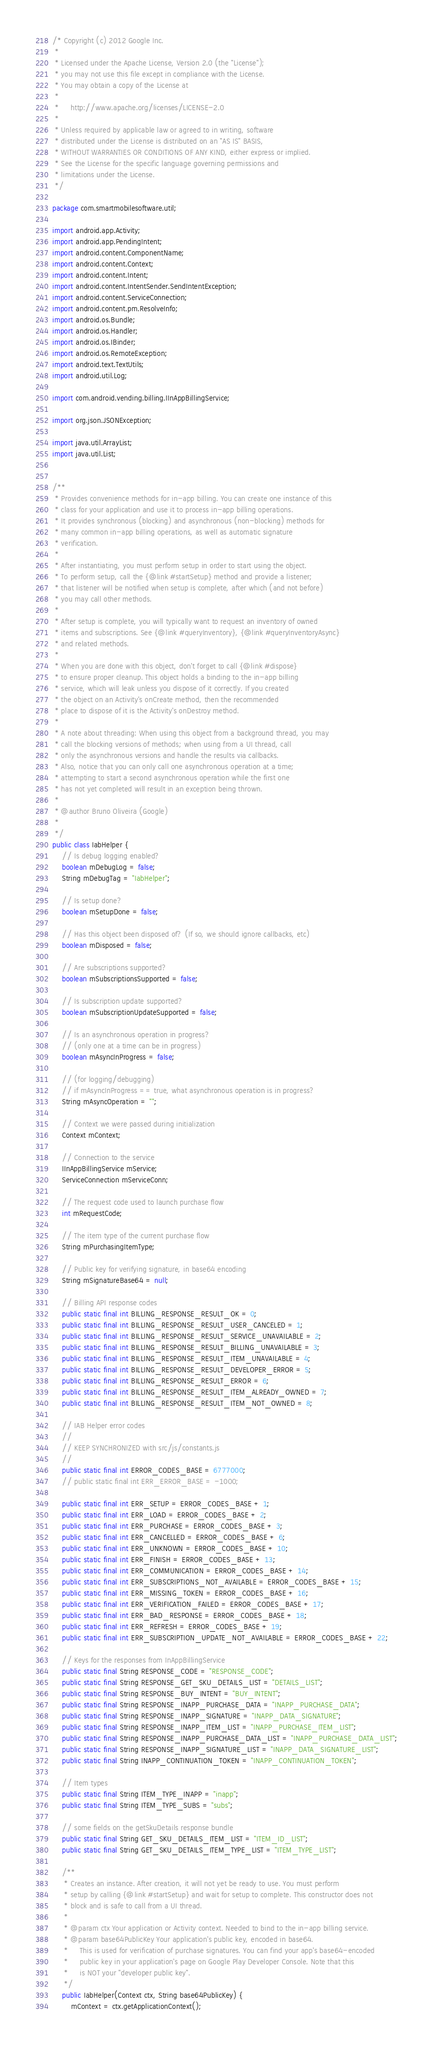<code> <loc_0><loc_0><loc_500><loc_500><_Java_>/* Copyright (c) 2012 Google Inc.
 *
 * Licensed under the Apache License, Version 2.0 (the "License");
 * you may not use this file except in compliance with the License.
 * You may obtain a copy of the License at
 *
 *     http://www.apache.org/licenses/LICENSE-2.0
 *
 * Unless required by applicable law or agreed to in writing, software
 * distributed under the License is distributed on an "AS IS" BASIS,
 * WITHOUT WARRANTIES OR CONDITIONS OF ANY KIND, either express or implied.
 * See the License for the specific language governing permissions and
 * limitations under the License.
 */

package com.smartmobilesoftware.util;

import android.app.Activity;
import android.app.PendingIntent;
import android.content.ComponentName;
import android.content.Context;
import android.content.Intent;
import android.content.IntentSender.SendIntentException;
import android.content.ServiceConnection;
import android.content.pm.ResolveInfo;
import android.os.Bundle;
import android.os.Handler;
import android.os.IBinder;
import android.os.RemoteException;
import android.text.TextUtils;
import android.util.Log;

import com.android.vending.billing.IInAppBillingService;

import org.json.JSONException;

import java.util.ArrayList;
import java.util.List;


/**
 * Provides convenience methods for in-app billing. You can create one instance of this
 * class for your application and use it to process in-app billing operations.
 * It provides synchronous (blocking) and asynchronous (non-blocking) methods for
 * many common in-app billing operations, as well as automatic signature
 * verification.
 *
 * After instantiating, you must perform setup in order to start using the object.
 * To perform setup, call the {@link #startSetup} method and provide a listener;
 * that listener will be notified when setup is complete, after which (and not before)
 * you may call other methods.
 *
 * After setup is complete, you will typically want to request an inventory of owned
 * items and subscriptions. See {@link #queryInventory}, {@link #queryInventoryAsync}
 * and related methods.
 *
 * When you are done with this object, don't forget to call {@link #dispose}
 * to ensure proper cleanup. This object holds a binding to the in-app billing
 * service, which will leak unless you dispose of it correctly. If you created
 * the object on an Activity's onCreate method, then the recommended
 * place to dispose of it is the Activity's onDestroy method.
 *
 * A note about threading: When using this object from a background thread, you may
 * call the blocking versions of methods; when using from a UI thread, call
 * only the asynchronous versions and handle the results via callbacks.
 * Also, notice that you can only call one asynchronous operation at a time;
 * attempting to start a second asynchronous operation while the first one
 * has not yet completed will result in an exception being thrown.
 *
 * @author Bruno Oliveira (Google)
 *
 */
public class IabHelper {
    // Is debug logging enabled?
    boolean mDebugLog = false;
    String mDebugTag = "IabHelper";

    // Is setup done?
    boolean mSetupDone = false;

    // Has this object been disposed of? (If so, we should ignore callbacks, etc)
    boolean mDisposed = false;

    // Are subscriptions supported?
    boolean mSubscriptionsSupported = false;

    // Is subscription update supported?
    boolean mSubscriptionUpdateSupported = false;

    // Is an asynchronous operation in progress?
    // (only one at a time can be in progress)
    boolean mAsyncInProgress = false;

    // (for logging/debugging)
    // if mAsyncInProgress == true, what asynchronous operation is in progress?
    String mAsyncOperation = "";

    // Context we were passed during initialization
    Context mContext;

    // Connection to the service
    IInAppBillingService mService;
    ServiceConnection mServiceConn;

    // The request code used to launch purchase flow
    int mRequestCode;

    // The item type of the current purchase flow
    String mPurchasingItemType;

    // Public key for verifying signature, in base64 encoding
    String mSignatureBase64 = null;

    // Billing API response codes
    public static final int BILLING_RESPONSE_RESULT_OK = 0;
    public static final int BILLING_RESPONSE_RESULT_USER_CANCELED = 1;
    public static final int BILLING_RESPONSE_RESULT_SERVICE_UNAVAILABLE = 2;
    public static final int BILLING_RESPONSE_RESULT_BILLING_UNAVAILABLE = 3;
    public static final int BILLING_RESPONSE_RESULT_ITEM_UNAVAILABLE = 4;
    public static final int BILLING_RESPONSE_RESULT_DEVELOPER_ERROR = 5;
    public static final int BILLING_RESPONSE_RESULT_ERROR = 6;
    public static final int BILLING_RESPONSE_RESULT_ITEM_ALREADY_OWNED = 7;
    public static final int BILLING_RESPONSE_RESULT_ITEM_NOT_OWNED = 8;

    // IAB Helper error codes
    //
    // KEEP SYNCHRONIZED with src/js/constants.js
    //
    public static final int ERROR_CODES_BASE = 6777000;
    // public static final int ERR_ERROR_BASE = -1000;

    public static final int ERR_SETUP = ERROR_CODES_BASE + 1;
    public static final int ERR_LOAD = ERROR_CODES_BASE + 2;
    public static final int ERR_PURCHASE = ERROR_CODES_BASE + 3;
    public static final int ERR_CANCELLED = ERROR_CODES_BASE + 6;
    public static final int ERR_UNKNOWN = ERROR_CODES_BASE + 10;
    public static final int ERR_FINISH = ERROR_CODES_BASE + 13;
    public static final int ERR_COMMUNICATION = ERROR_CODES_BASE + 14;
    public static final int ERR_SUBSCRIPTIONS_NOT_AVAILABLE = ERROR_CODES_BASE + 15;
    public static final int ERR_MISSING_TOKEN = ERROR_CODES_BASE + 16;
    public static final int ERR_VERIFICATION_FAILED = ERROR_CODES_BASE + 17;
    public static final int ERR_BAD_RESPONSE = ERROR_CODES_BASE + 18;
    public static final int ERR_REFRESH = ERROR_CODES_BASE + 19;
    public static final int ERR_SUBSCRIPTION_UPDATE_NOT_AVAILABLE = ERROR_CODES_BASE + 22;

    // Keys for the responses from InAppBillingService
    public static final String RESPONSE_CODE = "RESPONSE_CODE";
    public static final String RESPONSE_GET_SKU_DETAILS_LIST = "DETAILS_LIST";
    public static final String RESPONSE_BUY_INTENT = "BUY_INTENT";
    public static final String RESPONSE_INAPP_PURCHASE_DATA = "INAPP_PURCHASE_DATA";
    public static final String RESPONSE_INAPP_SIGNATURE = "INAPP_DATA_SIGNATURE";
    public static final String RESPONSE_INAPP_ITEM_LIST = "INAPP_PURCHASE_ITEM_LIST";
    public static final String RESPONSE_INAPP_PURCHASE_DATA_LIST = "INAPP_PURCHASE_DATA_LIST";
    public static final String RESPONSE_INAPP_SIGNATURE_LIST = "INAPP_DATA_SIGNATURE_LIST";
    public static final String INAPP_CONTINUATION_TOKEN = "INAPP_CONTINUATION_TOKEN";

    // Item types
    public static final String ITEM_TYPE_INAPP = "inapp";
    public static final String ITEM_TYPE_SUBS = "subs";

    // some fields on the getSkuDetails response bundle
    public static final String GET_SKU_DETAILS_ITEM_LIST = "ITEM_ID_LIST";
    public static final String GET_SKU_DETAILS_ITEM_TYPE_LIST = "ITEM_TYPE_LIST";

    /**
     * Creates an instance. After creation, it will not yet be ready to use. You must perform
     * setup by calling {@link #startSetup} and wait for setup to complete. This constructor does not
     * block and is safe to call from a UI thread.
     *
     * @param ctx Your application or Activity context. Needed to bind to the in-app billing service.
     * @param base64PublicKey Your application's public key, encoded in base64.
     *     This is used for verification of purchase signatures. You can find your app's base64-encoded
     *     public key in your application's page on Google Play Developer Console. Note that this
     *     is NOT your "developer public key".
     */
    public IabHelper(Context ctx, String base64PublicKey) {
        mContext = ctx.getApplicationContext();</code> 